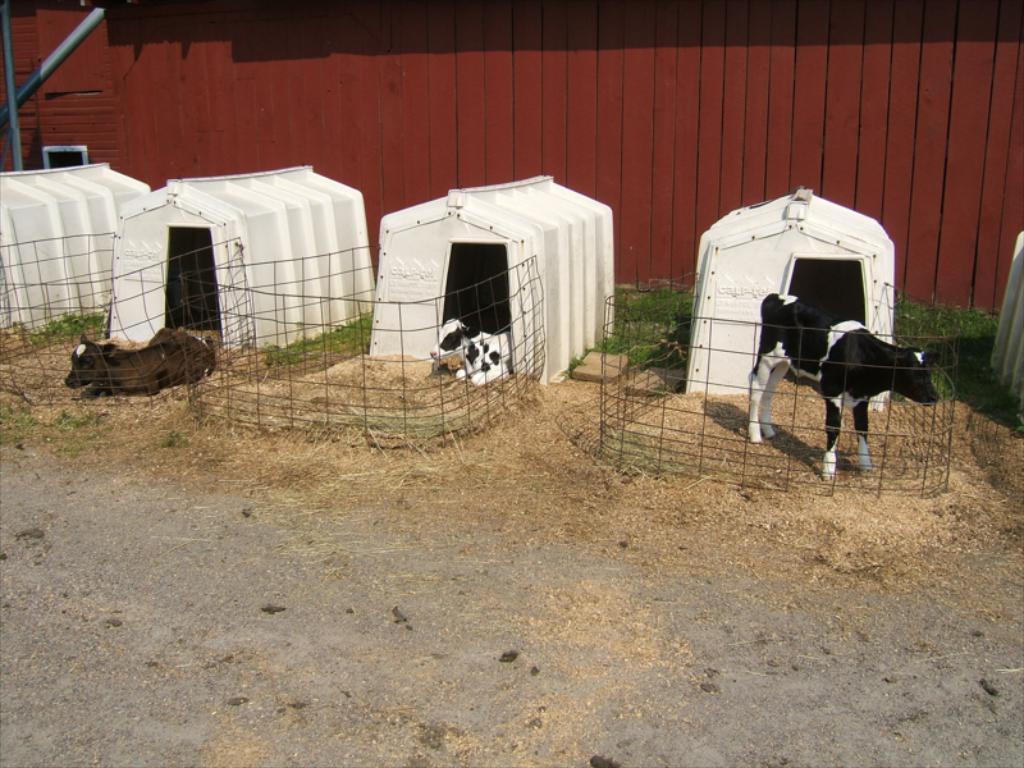Describe this image in one or two sentences. Here we can see two cows are sitting on the grass on the ground and on the right there is a cow standing on the ground at their sheds and we can see fences to each shed. In the background there is a wooden wall and o the left we can see poles. 